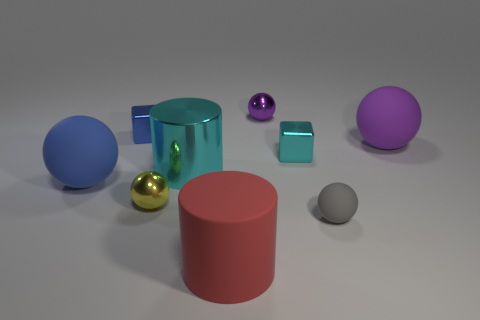Subtract all gray spheres. How many spheres are left? 4 Add 1 tiny rubber things. How many objects exist? 10 Subtract all red cylinders. How many cylinders are left? 1 Subtract 1 cubes. How many cubes are left? 1 Add 6 tiny blue blocks. How many tiny blue blocks are left? 7 Add 9 tiny gray balls. How many tiny gray balls exist? 10 Subtract 2 purple spheres. How many objects are left? 7 Subtract all cubes. How many objects are left? 7 Subtract all brown cubes. Subtract all brown spheres. How many cubes are left? 2 Subtract all gray cylinders. How many blue cubes are left? 1 